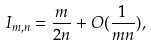Convert formula to latex. <formula><loc_0><loc_0><loc_500><loc_500>I _ { m , n } = \frac { m } { 2 n } + O ( \frac { 1 } { m n } ) ,</formula> 